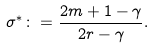Convert formula to latex. <formula><loc_0><loc_0><loc_500><loc_500>\sigma ^ { * } \colon = \frac { 2 m + 1 - \gamma } { 2 r - \gamma } .</formula> 